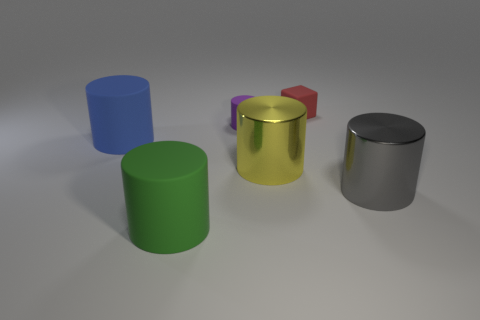How many big green cylinders are made of the same material as the red block?
Provide a succinct answer. 1. What is the color of the small cylinder that is the same material as the tiny red cube?
Give a very brief answer. Purple. There is a red block; is its size the same as the object to the right of the tiny block?
Offer a very short reply. No. What is the material of the large cylinder to the left of the rubber cylinder in front of the large cylinder on the right side of the tiny red matte cube?
Ensure brevity in your answer.  Rubber. How many objects are either large green rubber spheres or red cubes?
Make the answer very short. 1. Is the color of the metallic thing to the right of the tiny red object the same as the rubber cylinder in front of the yellow metal cylinder?
Offer a very short reply. No. There is a green thing that is the same size as the gray metal cylinder; what shape is it?
Make the answer very short. Cylinder. What number of objects are rubber cylinders that are left of the small purple thing or things in front of the red matte block?
Keep it short and to the point. 5. Are there fewer large green metallic blocks than rubber cubes?
Offer a terse response. Yes. There is a blue object that is the same size as the gray shiny thing; what is its material?
Your response must be concise. Rubber. 